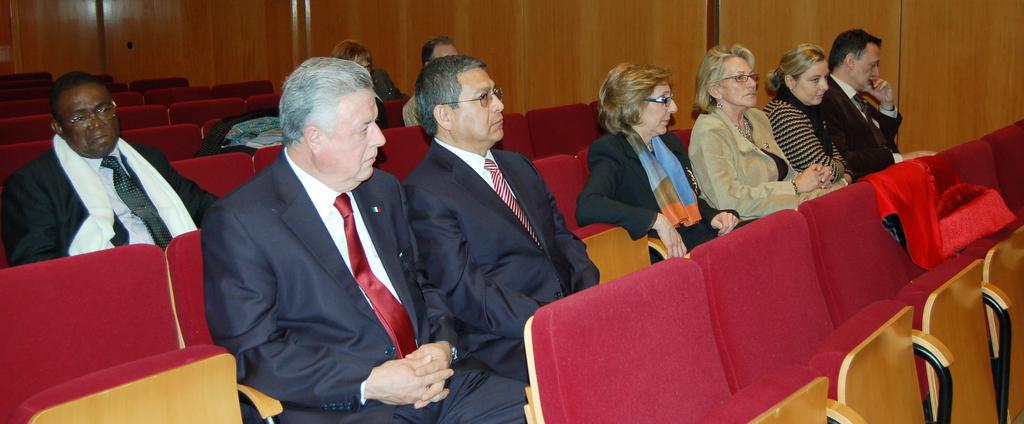Who or what can be seen in the image? There are people in the image. What are the people doing in the image? The people are sitting in chairs. What is the color of the chairs in the image? The chairs are red in color. Are there any markets visible in the image? There is no mention of a market in the provided facts, so it cannot be determined if one is visible in the image. 